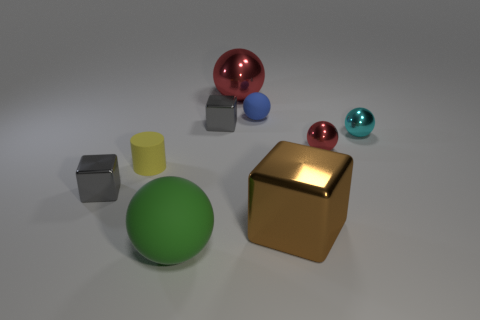What size is the metallic object that is the same color as the big metal ball?
Keep it short and to the point. Small. There is a tiny object that is the same color as the large metal sphere; what is its shape?
Ensure brevity in your answer.  Sphere. Is the number of big cubes that are to the right of the tiny red metallic thing the same as the number of large metallic objects?
Make the answer very short. No. There is a gray block that is in front of the small red metal ball; what size is it?
Make the answer very short. Small. How many tiny objects are cyan shiny objects or red metallic things?
Offer a very short reply. 2. What is the color of the other rubber object that is the same shape as the large green object?
Make the answer very short. Blue. Is the size of the yellow matte thing the same as the brown object?
Provide a succinct answer. No. How many objects are large yellow shiny cubes or metal objects that are in front of the big red metal sphere?
Your response must be concise. 5. There is a block in front of the small gray block in front of the cyan object; what color is it?
Give a very brief answer. Brown. Do the metal thing to the left of the tiny yellow cylinder and the big rubber object have the same color?
Provide a succinct answer. No. 